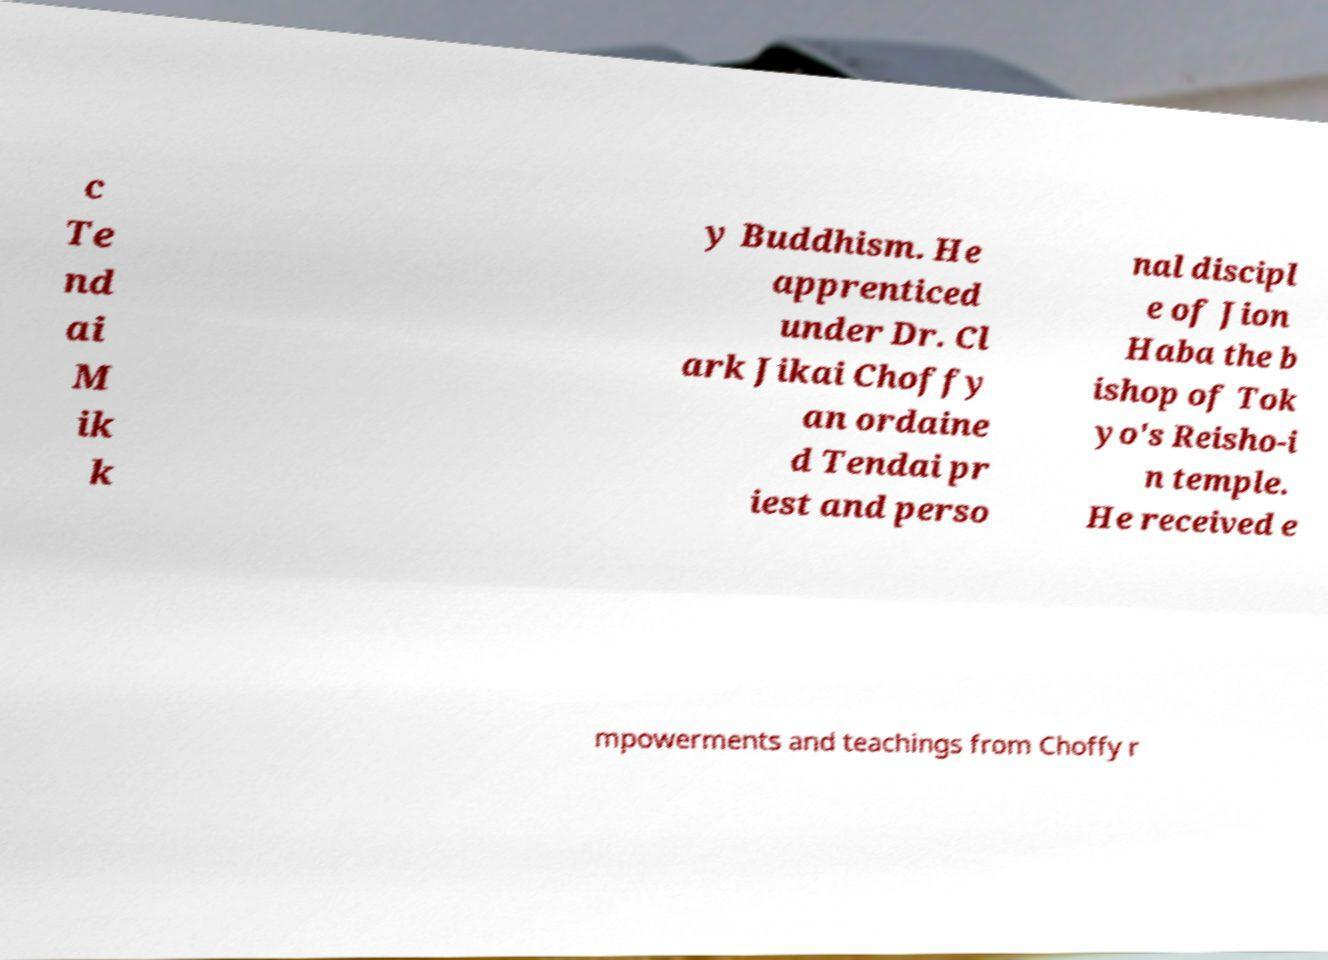For documentation purposes, I need the text within this image transcribed. Could you provide that? c Te nd ai M ik k y Buddhism. He apprenticed under Dr. Cl ark Jikai Choffy an ordaine d Tendai pr iest and perso nal discipl e of Jion Haba the b ishop of Tok yo's Reisho-i n temple. He received e mpowerments and teachings from Choffy r 